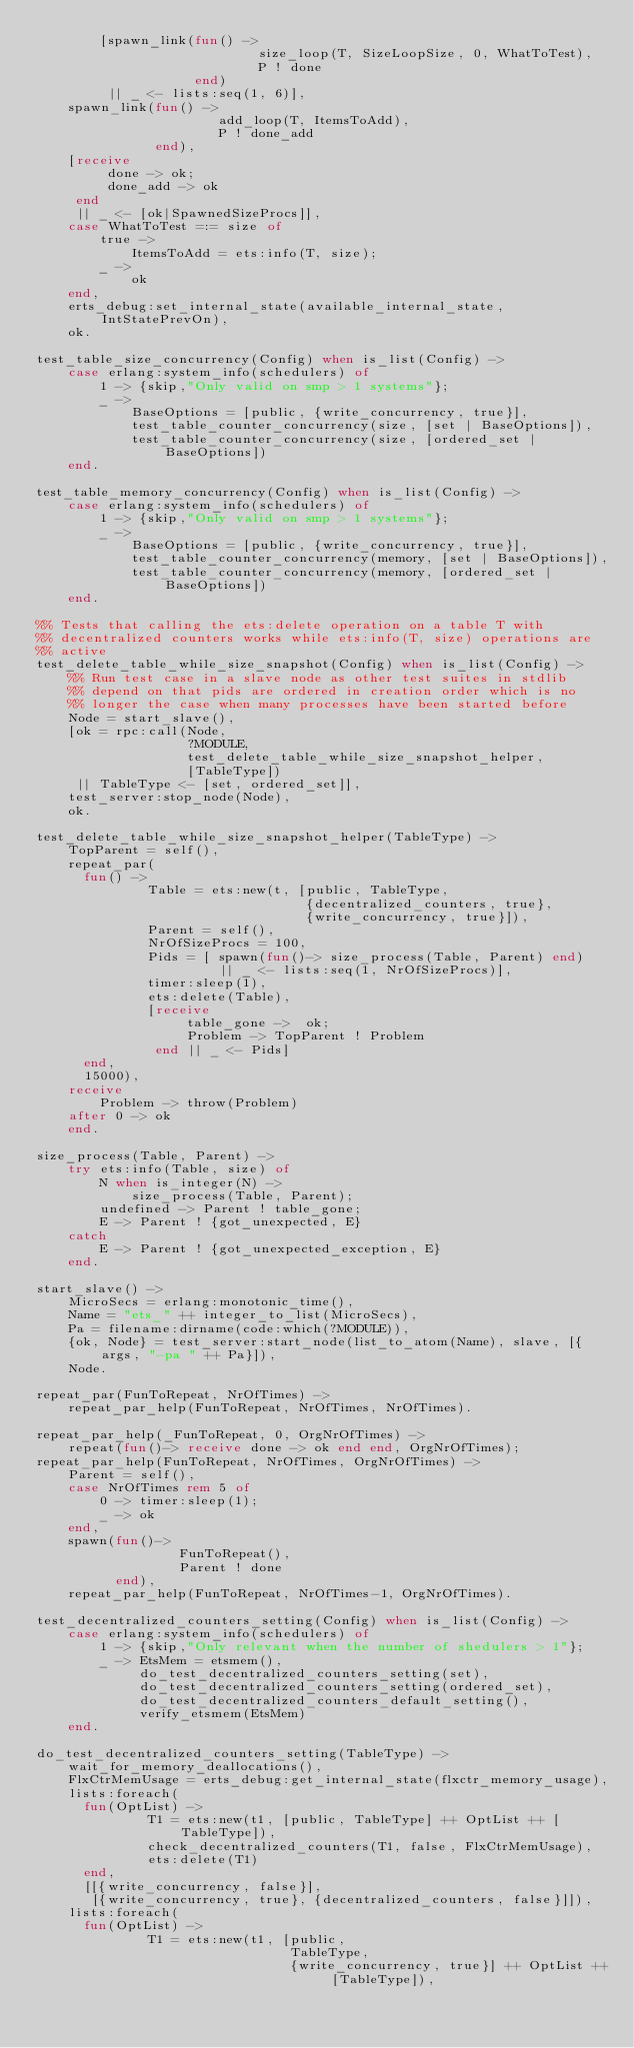Convert code to text. <code><loc_0><loc_0><loc_500><loc_500><_Erlang_>        [spawn_link(fun() ->
                            size_loop(T, SizeLoopSize, 0, WhatToTest),
                            P ! done
                    end)
         || _ <- lists:seq(1, 6)],
    spawn_link(fun() ->
                       add_loop(T, ItemsToAdd),
                       P ! done_add
               end),
    [receive
         done -> ok;
         done_add -> ok
     end
     || _ <- [ok|SpawnedSizeProcs]],
    case WhatToTest =:= size of
        true ->
            ItemsToAdd = ets:info(T, size);
        _ ->
            ok
    end,
    erts_debug:set_internal_state(available_internal_state, IntStatePrevOn),
    ok.

test_table_size_concurrency(Config) when is_list(Config) ->
    case erlang:system_info(schedulers) of
        1 -> {skip,"Only valid on smp > 1 systems"};
        _ ->
            BaseOptions = [public, {write_concurrency, true}],
            test_table_counter_concurrency(size, [set | BaseOptions]),
            test_table_counter_concurrency(size, [ordered_set | BaseOptions])
    end.

test_table_memory_concurrency(Config) when is_list(Config) ->
    case erlang:system_info(schedulers) of
        1 -> {skip,"Only valid on smp > 1 systems"};
        _ ->
            BaseOptions = [public, {write_concurrency, true}],
            test_table_counter_concurrency(memory, [set | BaseOptions]),
            test_table_counter_concurrency(memory, [ordered_set | BaseOptions])
    end.

%% Tests that calling the ets:delete operation on a table T with
%% decentralized counters works while ets:info(T, size) operations are
%% active
test_delete_table_while_size_snapshot(Config) when is_list(Config) ->
    %% Run test case in a slave node as other test suites in stdlib
    %% depend on that pids are ordered in creation order which is no
    %% longer the case when many processes have been started before
    Node = start_slave(),
    [ok = rpc:call(Node,
                   ?MODULE,
                   test_delete_table_while_size_snapshot_helper,
                   [TableType])
     || TableType <- [set, ordered_set]],
    test_server:stop_node(Node),
    ok.

test_delete_table_while_size_snapshot_helper(TableType) ->
    TopParent = self(),
    repeat_par(
      fun() ->
              Table = ets:new(t, [public, TableType,
                                  {decentralized_counters, true},
                                  {write_concurrency, true}]),
              Parent = self(),
              NrOfSizeProcs = 100,
              Pids = [ spawn(fun()-> size_process(Table, Parent) end)
                       || _ <- lists:seq(1, NrOfSizeProcs)],
              timer:sleep(1),
              ets:delete(Table),
              [receive
                   table_gone ->  ok;
                   Problem -> TopParent ! Problem
               end || _ <- Pids]
      end,
      15000),
    receive
        Problem -> throw(Problem)
    after 0 -> ok
    end.

size_process(Table, Parent) ->
    try ets:info(Table, size) of
        N when is_integer(N) ->
            size_process(Table, Parent);
        undefined -> Parent ! table_gone;
        E -> Parent ! {got_unexpected, E}
    catch
        E -> Parent ! {got_unexpected_exception, E}
    end.

start_slave() ->
    MicroSecs = erlang:monotonic_time(),
    Name = "ets_" ++ integer_to_list(MicroSecs),
    Pa = filename:dirname(code:which(?MODULE)),
    {ok, Node} = test_server:start_node(list_to_atom(Name), slave, [{args, "-pa " ++ Pa}]),
    Node.

repeat_par(FunToRepeat, NrOfTimes) ->
    repeat_par_help(FunToRepeat, NrOfTimes, NrOfTimes).

repeat_par_help(_FunToRepeat, 0, OrgNrOfTimes) ->
    repeat(fun()-> receive done -> ok end end, OrgNrOfTimes);
repeat_par_help(FunToRepeat, NrOfTimes, OrgNrOfTimes) ->
    Parent = self(),
    case NrOfTimes rem 5 of
        0 -> timer:sleep(1);
        _ -> ok
    end,
    spawn(fun()->
                  FunToRepeat(),
                  Parent ! done
          end),
    repeat_par_help(FunToRepeat, NrOfTimes-1, OrgNrOfTimes).

test_decentralized_counters_setting(Config) when is_list(Config) ->
    case erlang:system_info(schedulers) of
        1 -> {skip,"Only relevant when the number of shedulers > 1"};
        _ -> EtsMem = etsmem(),
             do_test_decentralized_counters_setting(set),
             do_test_decentralized_counters_setting(ordered_set),
             do_test_decentralized_counters_default_setting(),
             verify_etsmem(EtsMem)
    end.

do_test_decentralized_counters_setting(TableType) ->
    wait_for_memory_deallocations(),
    FlxCtrMemUsage = erts_debug:get_internal_state(flxctr_memory_usage),
    lists:foreach(
      fun(OptList) ->
              T1 = ets:new(t1, [public, TableType] ++ OptList ++ [TableType]),
              check_decentralized_counters(T1, false, FlxCtrMemUsage),
              ets:delete(T1)
      end,
      [[{write_concurrency, false}],
       [{write_concurrency, true}, {decentralized_counters, false}]]),
    lists:foreach(
      fun(OptList) ->
              T1 = ets:new(t1, [public,
                                TableType,
                                {write_concurrency, true}] ++ OptList ++ [TableType]),</code> 